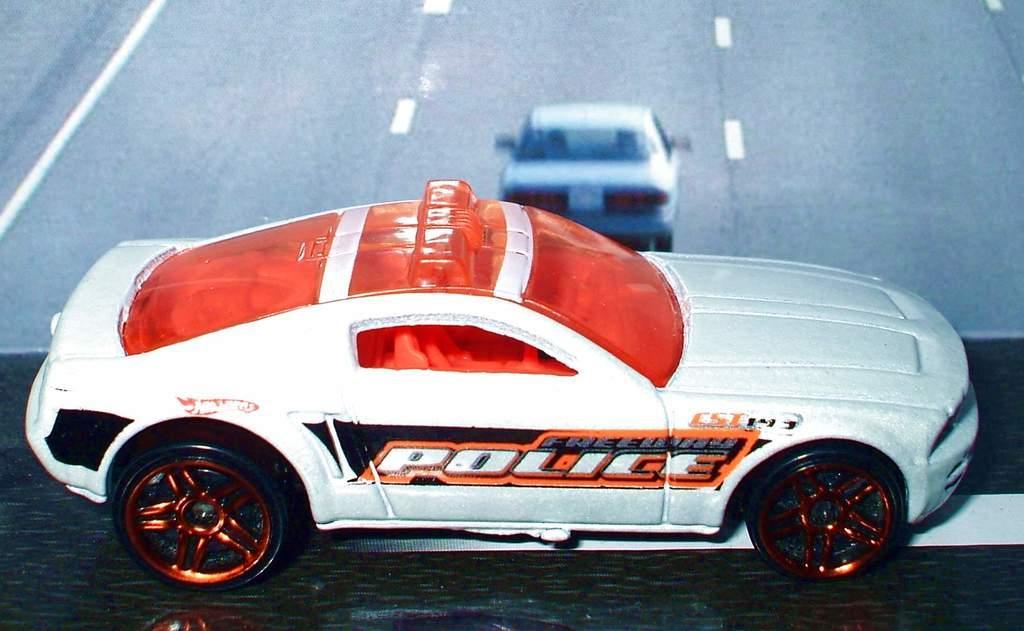In one or two sentences, can you explain what this image depicts? In this picture there is a toy car which is placed on the table. Beside that it might be the television screen. In that screen I can see the car which is running on the road. 